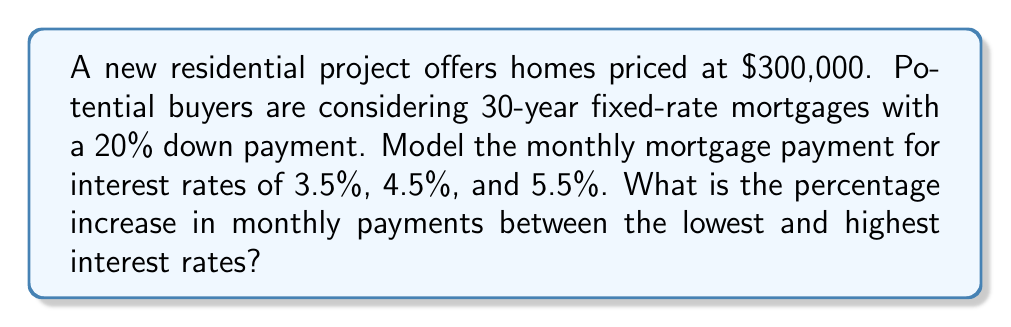Teach me how to tackle this problem. 1. Calculate the loan amount:
   Loan amount = Home price - Down payment
   $300,000 - (20% × $300,000) = $240,000

2. Use the mortgage payment formula:
   $$ P = L \frac{r(1+r)^n}{(1+r)^n-1} $$
   Where:
   P = Monthly payment
   L = Loan amount
   r = Monthly interest rate (annual rate ÷ 12)
   n = Total number of months (30 years × 12 months)

3. Calculate monthly payments for each interest rate:

   For 3.5%:
   $$ r = 0.035 ÷ 12 = 0.002917 $$
   $$ P = 240000 \frac{0.002917(1+0.002917)^{360}}{(1+0.002917)^{360}-1} = $1,077.71 $$

   For 4.5%:
   $$ r = 0.045 ÷ 12 = 0.00375 $$
   $$ P = 240000 \frac{0.00375(1+0.00375)^{360}}{(1+0.00375)^{360}-1} = $1,216.04 $$

   For 5.5%:
   $$ r = 0.055 ÷ 12 = 0.004583 $$
   $$ P = 240000 \frac{0.004583(1+0.004583)^{360}}{(1+0.004583)^{360}-1} = $1,361.41 $$

4. Calculate the percentage increase:
   $$ \text{Percentage increase} = \frac{\text{Highest payment} - \text{Lowest payment}}{\text{Lowest payment}} \times 100\% $$
   $$ = \frac{1361.41 - 1077.71}{1077.71} \times 100\% = 26.32\% $$
Answer: 26.32% 